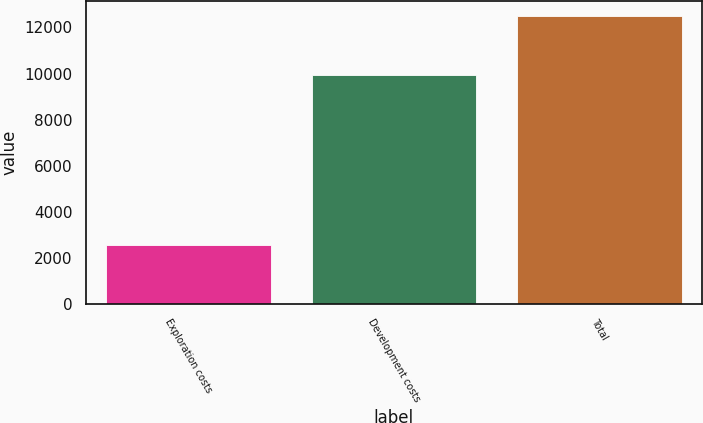Convert chart to OTSL. <chart><loc_0><loc_0><loc_500><loc_500><bar_chart><fcel>Exploration costs<fcel>Development costs<fcel>Total<nl><fcel>2560<fcel>9954<fcel>12514<nl></chart> 